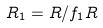<formula> <loc_0><loc_0><loc_500><loc_500>R _ { 1 } = R / f _ { 1 } R</formula> 